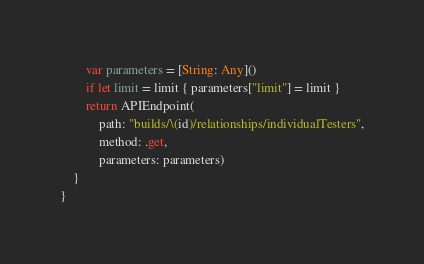<code> <loc_0><loc_0><loc_500><loc_500><_Swift_>        var parameters = [String: Any]()
        if let limit = limit { parameters["limit"] = limit }
        return APIEndpoint(
            path: "builds/\(id)/relationships/individualTesters",
            method: .get,
            parameters: parameters)
    }
}
</code> 